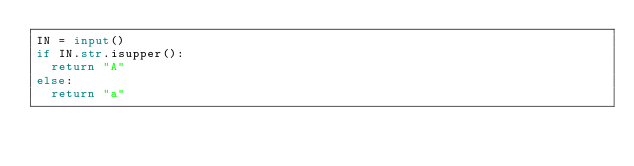<code> <loc_0><loc_0><loc_500><loc_500><_Python_>IN = input()
if IN.str.isupper():
  return "A"
else:
  return "a"</code> 